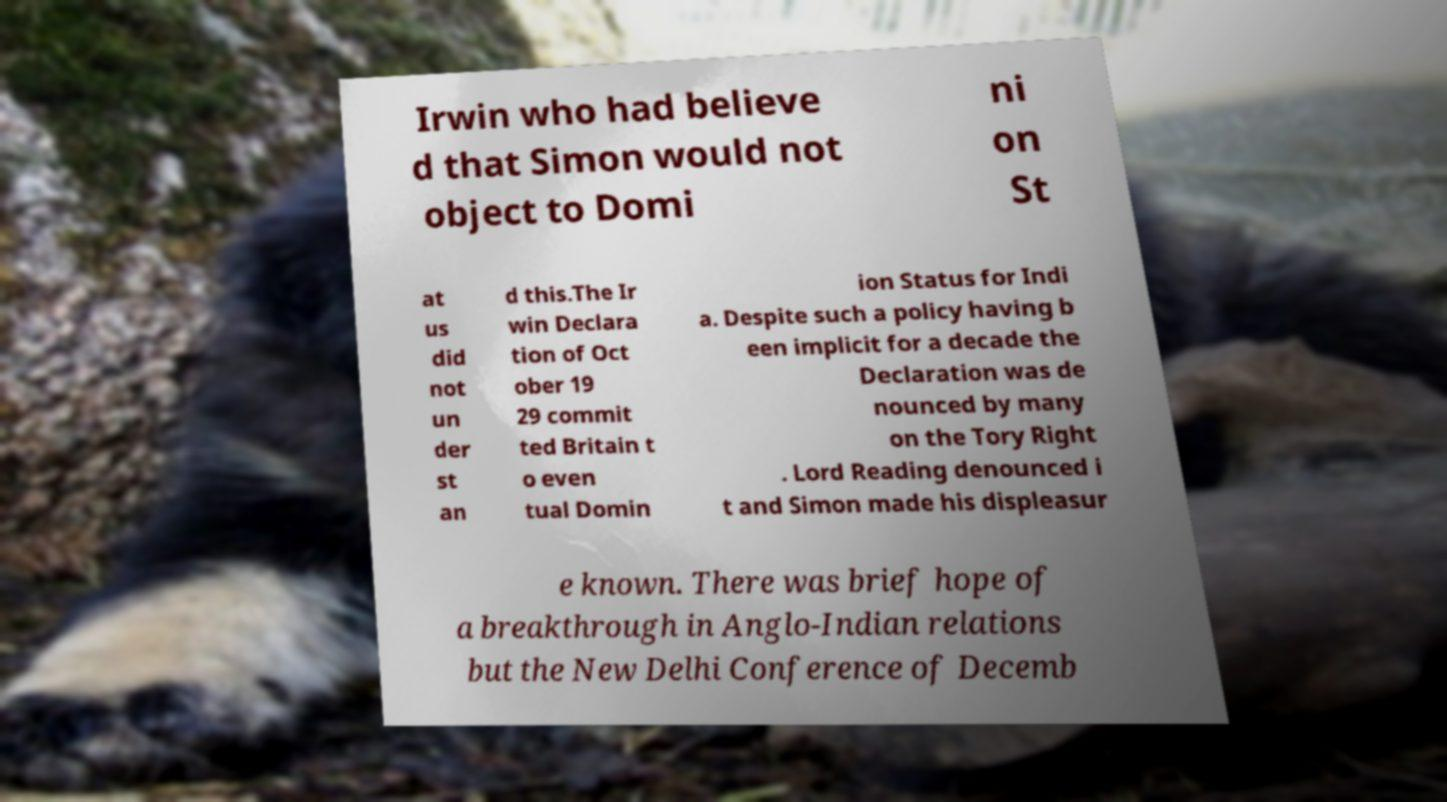Can you read and provide the text displayed in the image?This photo seems to have some interesting text. Can you extract and type it out for me? Irwin who had believe d that Simon would not object to Domi ni on St at us did not un der st an d this.The Ir win Declara tion of Oct ober 19 29 commit ted Britain t o even tual Domin ion Status for Indi a. Despite such a policy having b een implicit for a decade the Declaration was de nounced by many on the Tory Right . Lord Reading denounced i t and Simon made his displeasur e known. There was brief hope of a breakthrough in Anglo-Indian relations but the New Delhi Conference of Decemb 